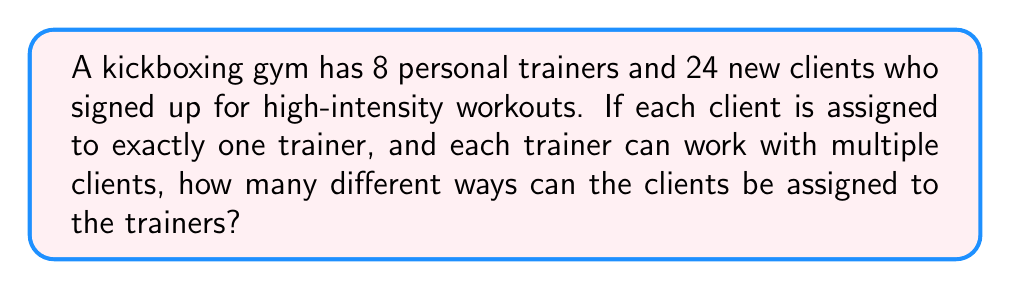Help me with this question. Let's approach this step-by-step:

1) This is a problem of distributing distinct objects (clients) into distinct boxes (trainers).

2) Each client has 8 choices for a trainer, as there are 8 trainers available.

3) The choices for each client are independent of the choices for other clients.

4) This scenario can be modeled using the multiplication principle.

5) For the first client, there are 8 choices.
   For the second client, there are 8 choices.
   This continues for all 24 clients.

6) Therefore, the total number of ways to assign clients to trainers is:

   $$8 \times 8 \times 8 \times ... \text{ (24 times)} = 8^{24}$$

7) We can write this more concisely as:

   $$8^{24}$$

This represents the total number of unique client-trainer pairings possible in the gym.
Answer: $8^{24}$ 